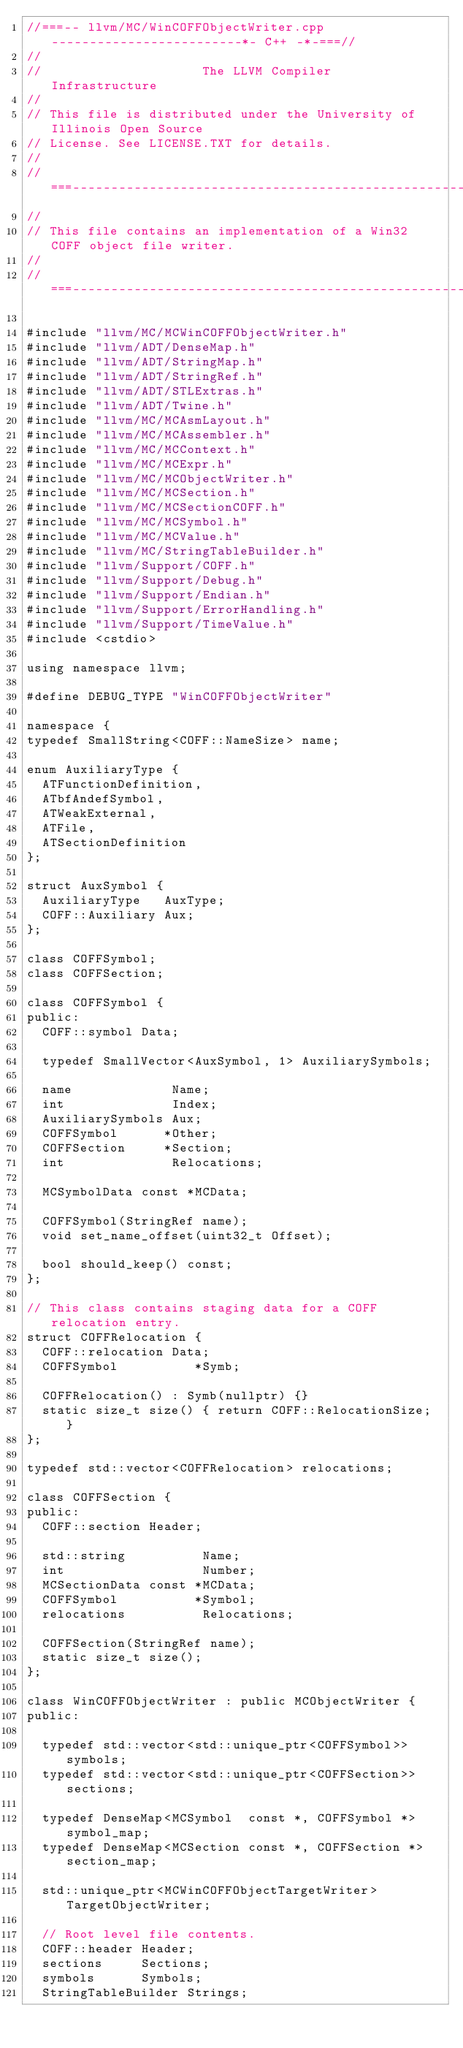<code> <loc_0><loc_0><loc_500><loc_500><_C++_>//===-- llvm/MC/WinCOFFObjectWriter.cpp -------------------------*- C++ -*-===//
//
//                     The LLVM Compiler Infrastructure
//
// This file is distributed under the University of Illinois Open Source
// License. See LICENSE.TXT for details.
//
//===----------------------------------------------------------------------===//
//
// This file contains an implementation of a Win32 COFF object file writer.
//
//===----------------------------------------------------------------------===//

#include "llvm/MC/MCWinCOFFObjectWriter.h"
#include "llvm/ADT/DenseMap.h"
#include "llvm/ADT/StringMap.h"
#include "llvm/ADT/StringRef.h"
#include "llvm/ADT/STLExtras.h"
#include "llvm/ADT/Twine.h"
#include "llvm/MC/MCAsmLayout.h"
#include "llvm/MC/MCAssembler.h"
#include "llvm/MC/MCContext.h"
#include "llvm/MC/MCExpr.h"
#include "llvm/MC/MCObjectWriter.h"
#include "llvm/MC/MCSection.h"
#include "llvm/MC/MCSectionCOFF.h"
#include "llvm/MC/MCSymbol.h"
#include "llvm/MC/MCValue.h"
#include "llvm/MC/StringTableBuilder.h"
#include "llvm/Support/COFF.h"
#include "llvm/Support/Debug.h"
#include "llvm/Support/Endian.h"
#include "llvm/Support/ErrorHandling.h"
#include "llvm/Support/TimeValue.h"
#include <cstdio>

using namespace llvm;

#define DEBUG_TYPE "WinCOFFObjectWriter"

namespace {
typedef SmallString<COFF::NameSize> name;

enum AuxiliaryType {
  ATFunctionDefinition,
  ATbfAndefSymbol,
  ATWeakExternal,
  ATFile,
  ATSectionDefinition
};

struct AuxSymbol {
  AuxiliaryType   AuxType;
  COFF::Auxiliary Aux;
};

class COFFSymbol;
class COFFSection;

class COFFSymbol {
public:
  COFF::symbol Data;

  typedef SmallVector<AuxSymbol, 1> AuxiliarySymbols;

  name             Name;
  int              Index;
  AuxiliarySymbols Aux;
  COFFSymbol      *Other;
  COFFSection     *Section;
  int              Relocations;

  MCSymbolData const *MCData;

  COFFSymbol(StringRef name);
  void set_name_offset(uint32_t Offset);

  bool should_keep() const;
};

// This class contains staging data for a COFF relocation entry.
struct COFFRelocation {
  COFF::relocation Data;
  COFFSymbol          *Symb;

  COFFRelocation() : Symb(nullptr) {}
  static size_t size() { return COFF::RelocationSize; }
};

typedef std::vector<COFFRelocation> relocations;

class COFFSection {
public:
  COFF::section Header;

  std::string          Name;
  int                  Number;
  MCSectionData const *MCData;
  COFFSymbol          *Symbol;
  relocations          Relocations;

  COFFSection(StringRef name);
  static size_t size();
};

class WinCOFFObjectWriter : public MCObjectWriter {
public:

  typedef std::vector<std::unique_ptr<COFFSymbol>>  symbols;
  typedef std::vector<std::unique_ptr<COFFSection>> sections;

  typedef DenseMap<MCSymbol  const *, COFFSymbol *>   symbol_map;
  typedef DenseMap<MCSection const *, COFFSection *> section_map;

  std::unique_ptr<MCWinCOFFObjectTargetWriter> TargetObjectWriter;

  // Root level file contents.
  COFF::header Header;
  sections     Sections;
  symbols      Symbols;
  StringTableBuilder Strings;
</code> 